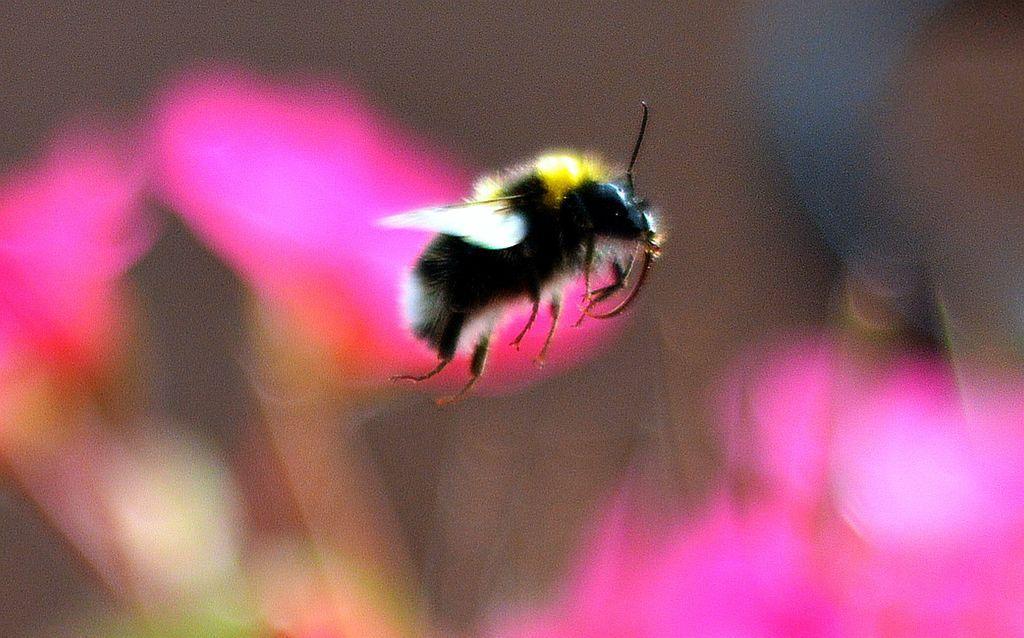Describe this image in one or two sentences. In the center of the image there is a fly. In the background we can see flowers. 